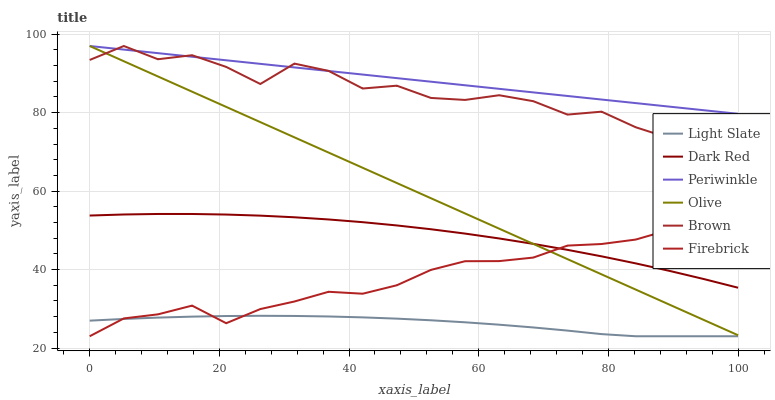Does Light Slate have the minimum area under the curve?
Answer yes or no. Yes. Does Periwinkle have the maximum area under the curve?
Answer yes or no. Yes. Does Dark Red have the minimum area under the curve?
Answer yes or no. No. Does Dark Red have the maximum area under the curve?
Answer yes or no. No. Is Periwinkle the smoothest?
Answer yes or no. Yes. Is Brown the roughest?
Answer yes or no. Yes. Is Light Slate the smoothest?
Answer yes or no. No. Is Light Slate the roughest?
Answer yes or no. No. Does Light Slate have the lowest value?
Answer yes or no. Yes. Does Dark Red have the lowest value?
Answer yes or no. No. Does Olive have the highest value?
Answer yes or no. Yes. Does Dark Red have the highest value?
Answer yes or no. No. Is Dark Red less than Brown?
Answer yes or no. Yes. Is Brown greater than Firebrick?
Answer yes or no. Yes. Does Brown intersect Periwinkle?
Answer yes or no. Yes. Is Brown less than Periwinkle?
Answer yes or no. No. Is Brown greater than Periwinkle?
Answer yes or no. No. Does Dark Red intersect Brown?
Answer yes or no. No. 